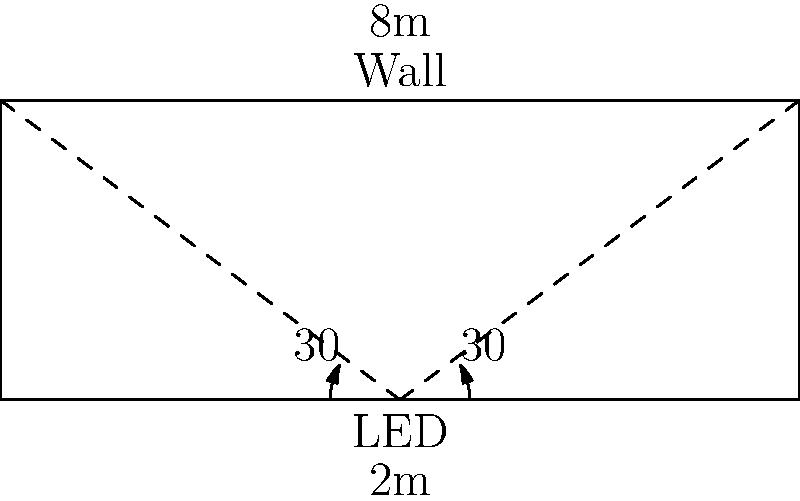An LED indicator light is mounted on a doorbell system 2 meters below a flat surface. The LED has a beam angle of 60° (30° on each side of the center). If the illuminated area on the surface is 8 meters wide, what is the height of the illuminated area above the LED? To solve this problem, we'll use trigonometry:

1) First, let's identify the known values:
   - The LED is 2 meters below the surface
   - The total beam angle is 60° (30° on each side)
   - The width of the illuminated area is 8 meters

2) We can split the problem into two right triangles. Each triangle has:
   - An angle of 30° at the LED
   - A base that's half of the total width (8/2 = 4 meters)

3) In one of these right triangles, we need to find the height. We can use the tangent function:

   $\tan(30°) = \frac{\text{opposite}}{\text{adjacent}} = \frac{\text{height}}{4}$

4) We know that $\tan(30°) = \frac{1}{\sqrt{3}}$, so:

   $\frac{1}{\sqrt{3}} = \frac{\text{height}}{4}$

5) Solving for height:
   $\text{height} = 4 \cdot \frac{1}{\sqrt{3}} = \frac{4}{\sqrt{3}} \approx 2.31$ meters

6) This is the height above the LED. To get the total height from the surface:

   $\text{total height} = 2.31 + 2 = 4.31$ meters

Therefore, the height of the illuminated area above the LED is approximately 2.31 meters, and the total height from the surface where the LED is mounted is 4.31 meters.
Answer: 2.31 meters above the LED (4.31 meters from the mounting surface) 